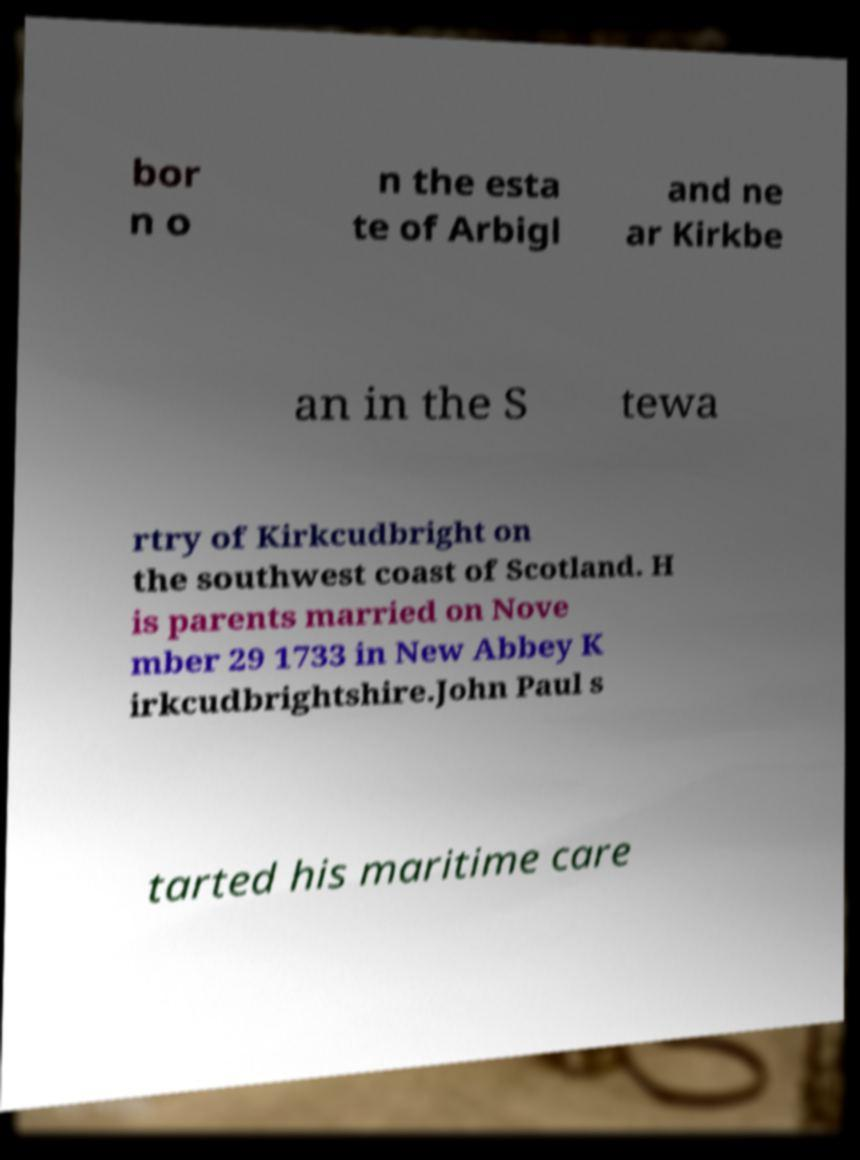For documentation purposes, I need the text within this image transcribed. Could you provide that? bor n o n the esta te of Arbigl and ne ar Kirkbe an in the S tewa rtry of Kirkcudbright on the southwest coast of Scotland. H is parents married on Nove mber 29 1733 in New Abbey K irkcudbrightshire.John Paul s tarted his maritime care 